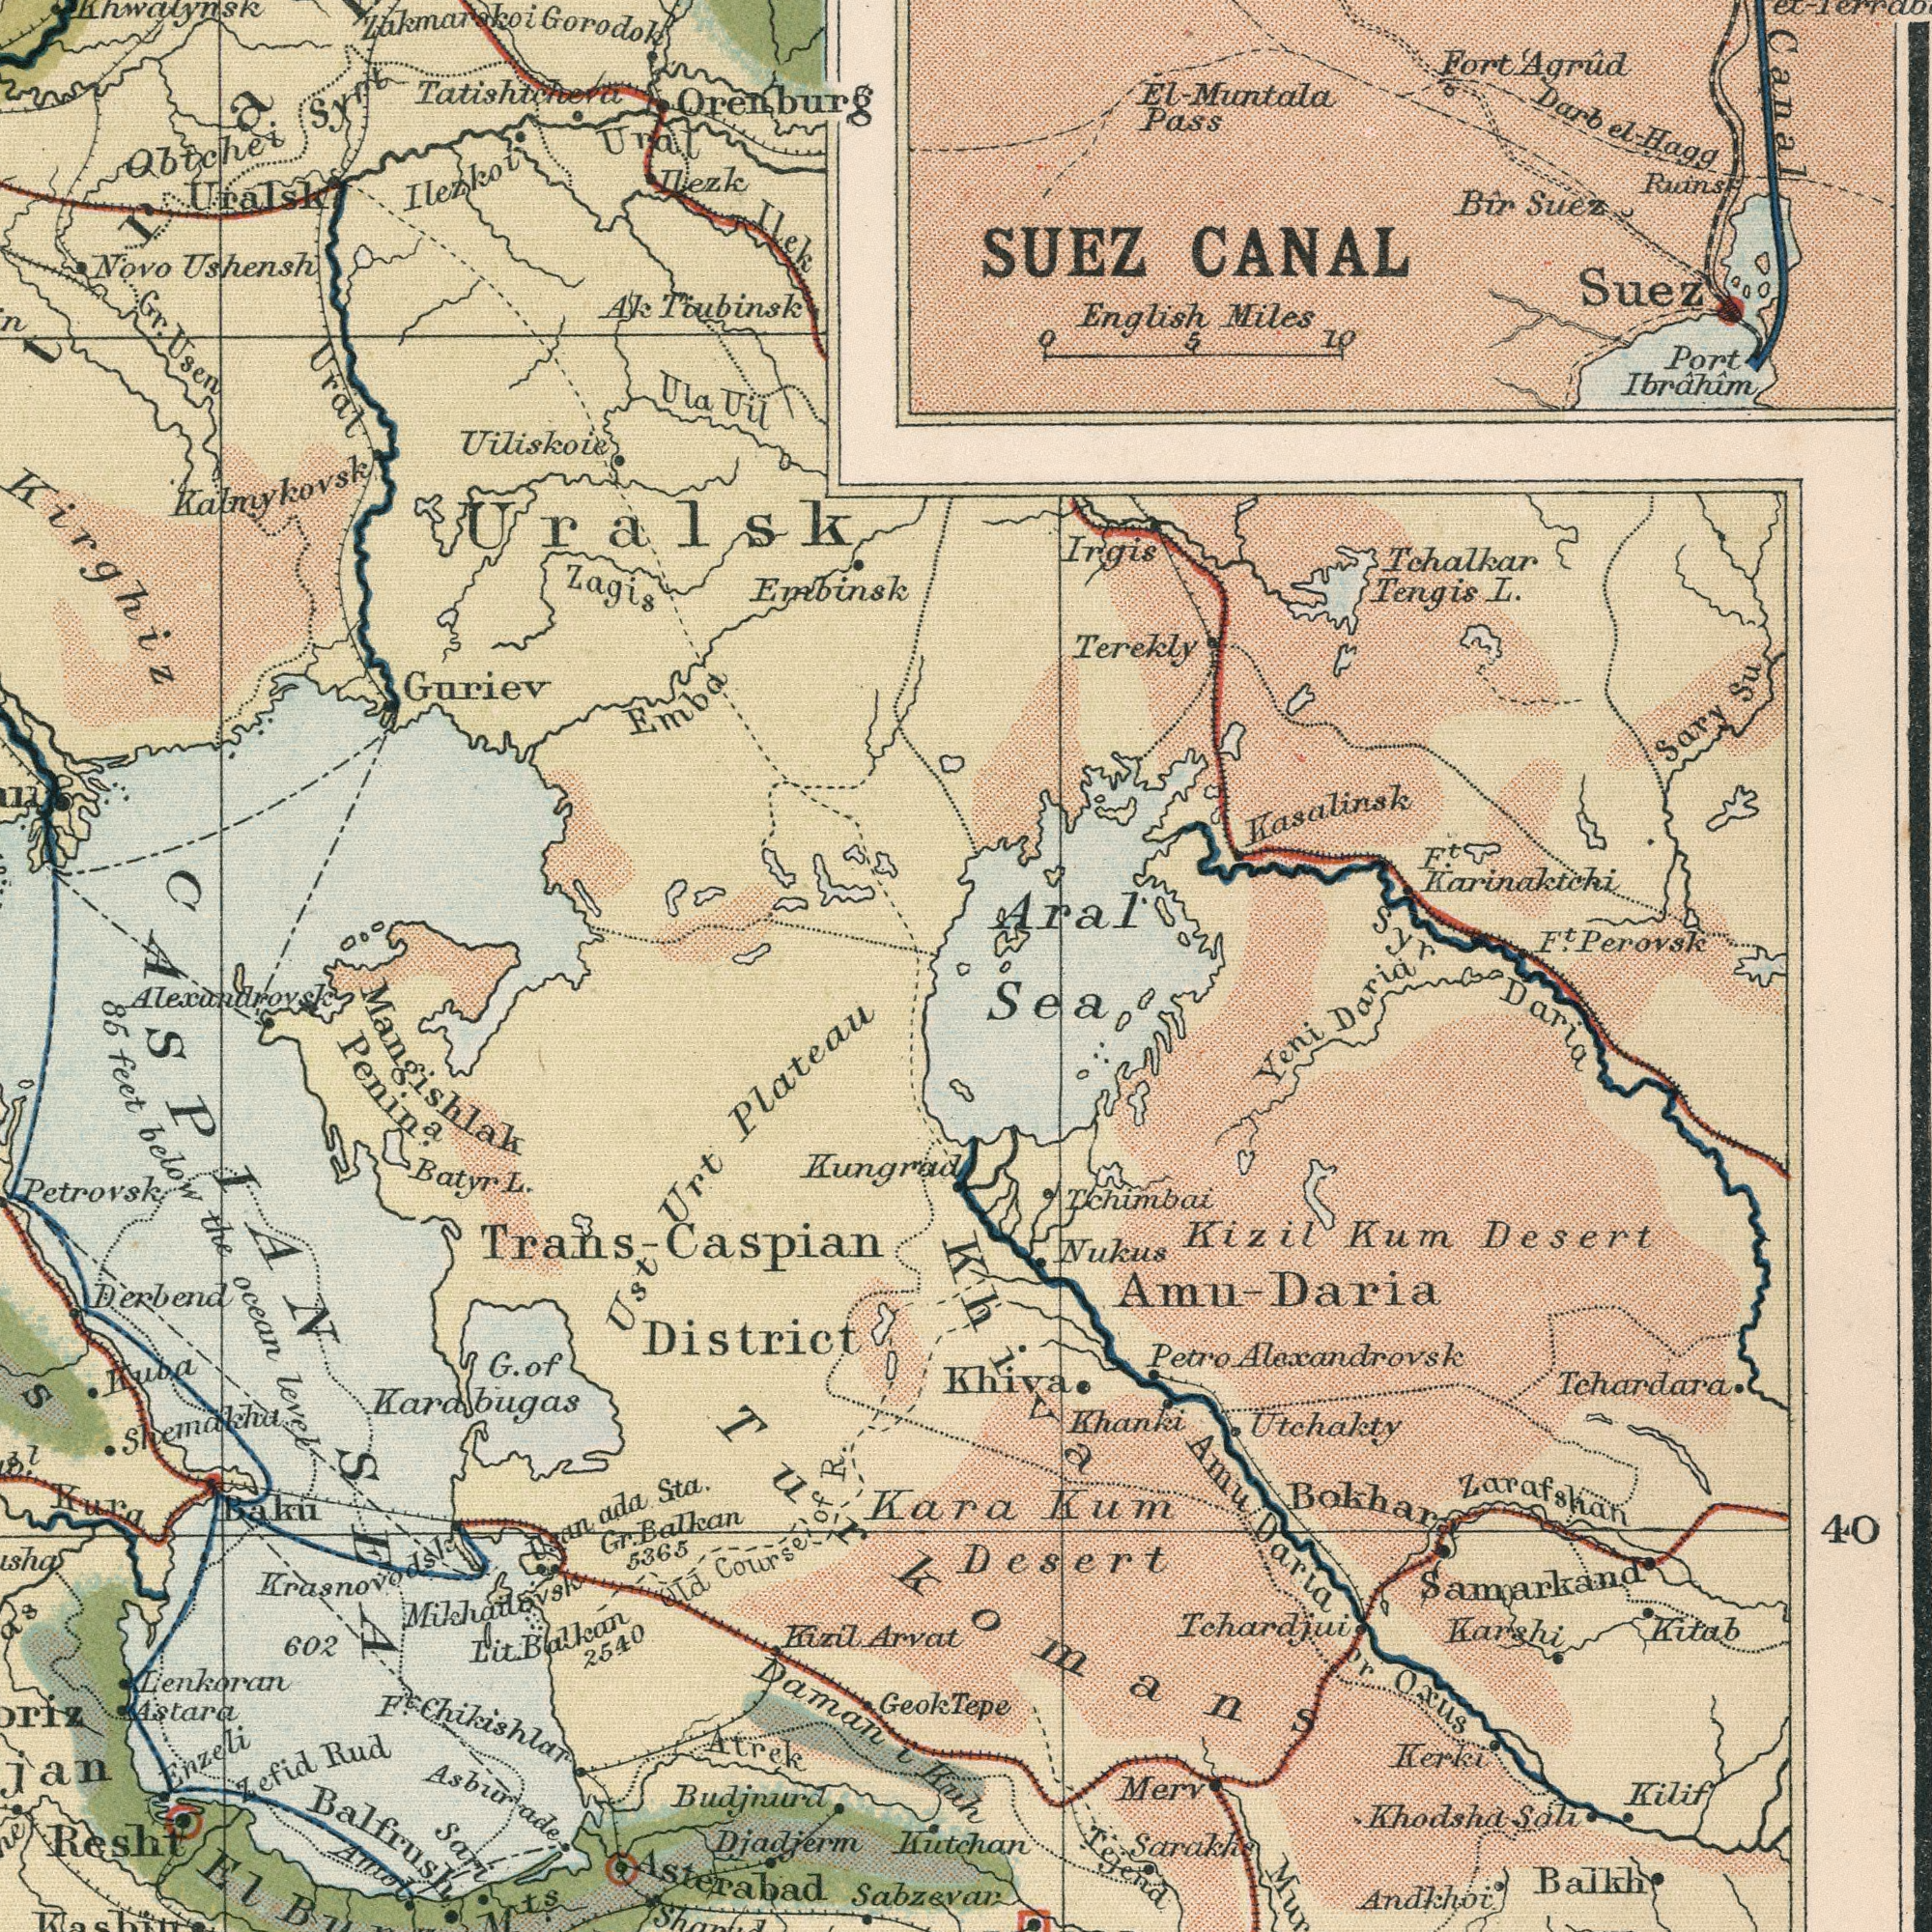What text appears in the top-left area of the image? Tiubinsk Gorodok Ilezk Ushensh Ilek Novo Uralsk Tatishtchera Urat Ural Guriev Embinsk Ak Zagis Orenburg Uiliskoie Uil Ula Syrt Ilezkoi Emba Usen Obtchei Uralsk Gr. Kirghiz Kalmykovsk Zakmarskoi Khwalynsk What text is visible in the lower-right corner? Kuh Desert Alexandrovsk Tchardara Andkhoi Khodsha Desert Tehardjui Kizil Utchakty Darla Khanki Oxus Kitab Nukus Petro Zarafshan Amu Khiva Balkh Kilif Kutchan Daria Bokhara Yeni Daria Kerki Karshi Sali Sea Tejend Tchimbai Kum Amu- Merv Kum Tepe Sarakhs or Samarkand 40 Daria Khiva Turkomans What text is visible in the lower-left corner? Karabugas District Daman Plateau 5365 Lenkoran Derbend Kungrad below Penin<sup>a</sup>. Amol Resht 602 Arvat Atrek level feet Rud Sta. Petrovsk ocean L. 2540 Kizil Geok Balkan Chikishlar Balkan Batyr Kura Trans- Sabzevar Alexandrovsk Urt Kuba Mikhailovsk Lit. Gr. the Djadjerm Shemakha Budjnurd Course F<sup>t</sup>. Astara Old ada Balfrush Mangishlak Zefid Asterabad Sari 85 ###S i Osan Enzeli Caspian Asburade Ust G. Kara of Krasnovodsk CASPIAN Baku SEA OF R. El M<sup>ts</sup>. What text appears in the top-right area of the image? CANAL SUEZ Canal Perovsk English Pass Muntala Kasalinsk Miles Terekly Karinaktchi Port Tengis Irgis Suez Suez Ruins F<sup>t</sup>. Sary Su el-Hagg Bir F<sup>t</sup>. L. Aral Fort Darb Agrûd Syr 10 Tchalkar Ibrâhâm 5 0 El- el- 